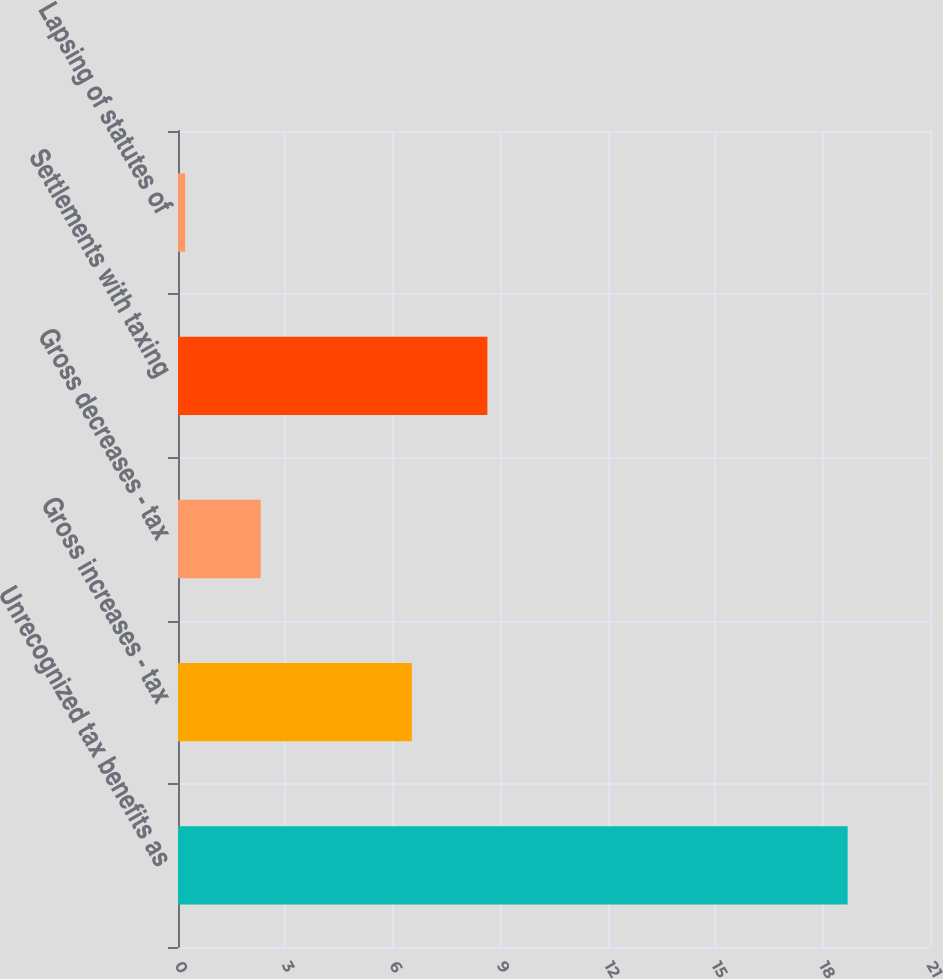<chart> <loc_0><loc_0><loc_500><loc_500><bar_chart><fcel>Unrecognized tax benefits as<fcel>Gross increases - tax<fcel>Gross decreases - tax<fcel>Settlements with taxing<fcel>Lapsing of statutes of<nl><fcel>18.7<fcel>6.53<fcel>2.31<fcel>8.64<fcel>0.2<nl></chart> 